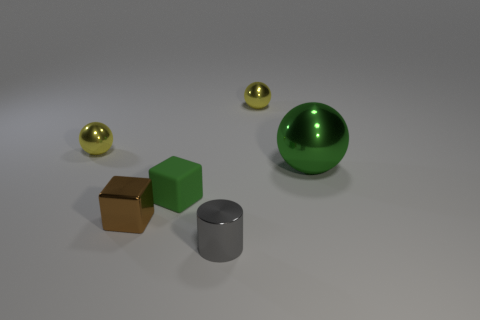Subtract all small yellow metal spheres. How many spheres are left? 1 Subtract all green spheres. How many spheres are left? 2 Subtract all cylinders. How many objects are left? 5 Add 2 tiny green matte cubes. How many objects exist? 8 Add 3 tiny yellow metallic things. How many tiny yellow metallic things exist? 5 Subtract 0 brown spheres. How many objects are left? 6 Subtract 2 cubes. How many cubes are left? 0 Subtract all yellow cylinders. Subtract all green balls. How many cylinders are left? 1 Subtract all blue cubes. How many green balls are left? 1 Subtract all big brown matte spheres. Subtract all tiny yellow metal things. How many objects are left? 4 